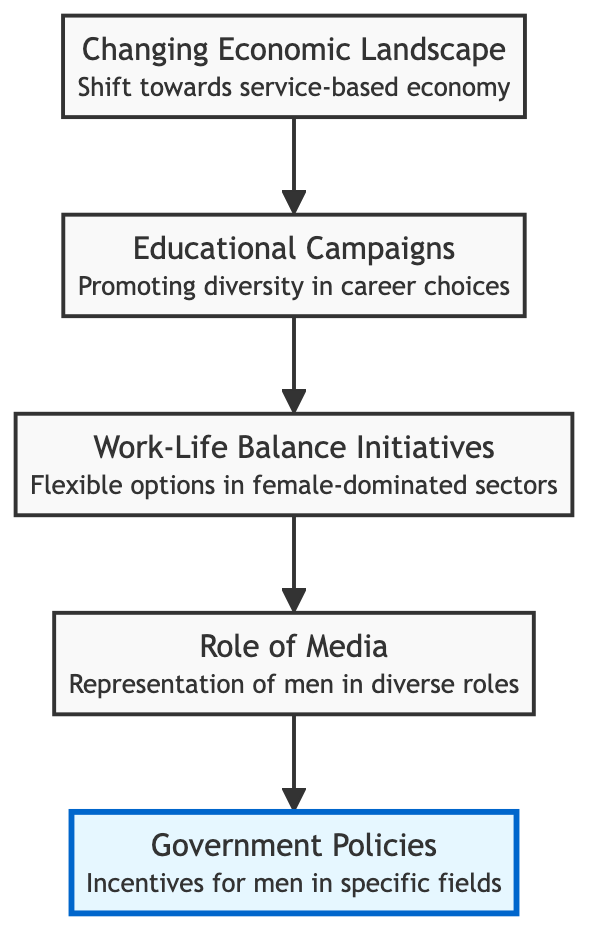What is the top element in the diagram? The top element is "Government Policies." According to the flowchart's structure, the topmost position is represented by the node labeled "Government Policies."
Answer: Government Policies How many levels are there in the diagram? The diagram has five levels: Bottom, Above Bottom, Middle, Above Middle, and Top. Each level corresponds to a different stage in the flow of factors contributing to male participation in female-dominated fields.
Answer: 5 What connects "Work-Life Balance Initiatives" to "Role of Media"? "Work-Life Balance Initiatives" connects to "Role of Media" through a direct arrow indicating progression. This shows that after the introduction of work-life initiatives, the next element in the flow is the role that media plays in representing men in the workforce.
Answer: An arrow Which element is immediately above "Educational Campaigns"? "Work-Life Balance Initiatives" is the element immediately above "Educational Campaigns." The diagram shows the flow from educational campaigns directly to work-life balance initiatives.
Answer: Work-Life Balance Initiatives Which node highlights a shift towards a service-based economy? "Changing Economic Landscape" highlights this shift. The description of this node specifically states that there has been a transition towards a service-based economy, creating opportunities in traditionally female-dominated areas.
Answer: Changing Economic Landscape What is the relationship between "Role of Media" and "Government Policies"? "Role of Media" is directly below "Government Policies," indicating that the influence of media is positioned before governmental actions and policies take effect, thereby contributing to societal changes over time.
Answer: Directly related What significant actions did legislation take regarding male participation? "Government Policies" signify these actions, such as grants and scholarships aimed at encouraging men to enter fields like early childhood education, addressing labor shortages. These actions are important for normalizing male participation in these fields.
Answer: Legislative actions Which factor is characterized by increased representation of men? "Role of Media" is characterized by this increased representation, as the node description indicates that media portrays men in various caregiving and educational roles. This media presence gradually normalizes these career paths for men.
Answer: Role of Media 